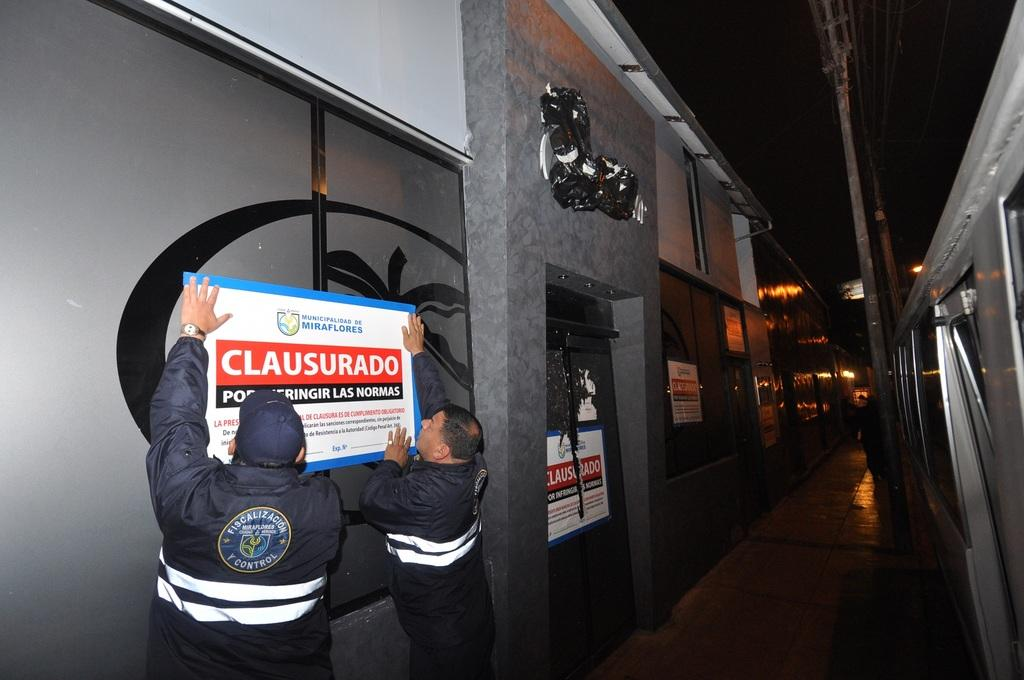What type of structures can be seen in the image? There are buildings in the image. What else is present on the buildings in the image? There are posters with text on the buildings. What are the men in the image doing? The men in the image are trying to stick a poster. What objects can be seen supporting the posters in the image? There are poles in the image. What type of insurance is being advertised on the posters in the image? There is no mention of insurance on the posters in the image. What type of nail is being used by the men to stick the poster in the image? There is no nail visible in the image; the men are trying to stick the poster without using a nail. 